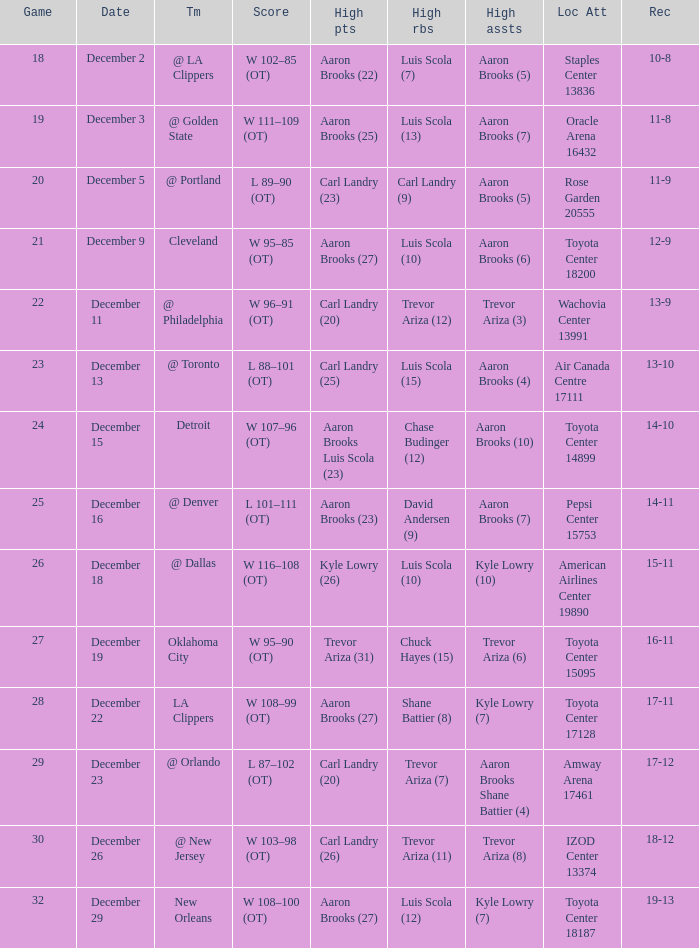Who did the high rebounds in the game where Carl Landry (23) did the most high points? Carl Landry (9). 